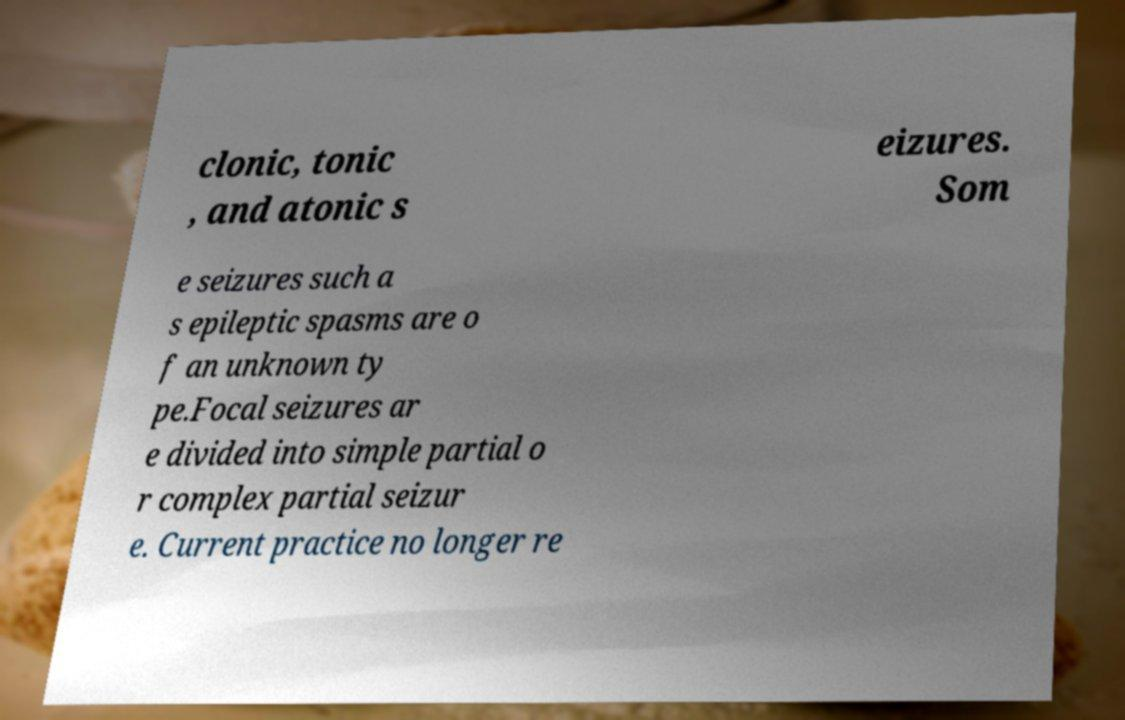Can you accurately transcribe the text from the provided image for me? clonic, tonic , and atonic s eizures. Som e seizures such a s epileptic spasms are o f an unknown ty pe.Focal seizures ar e divided into simple partial o r complex partial seizur e. Current practice no longer re 